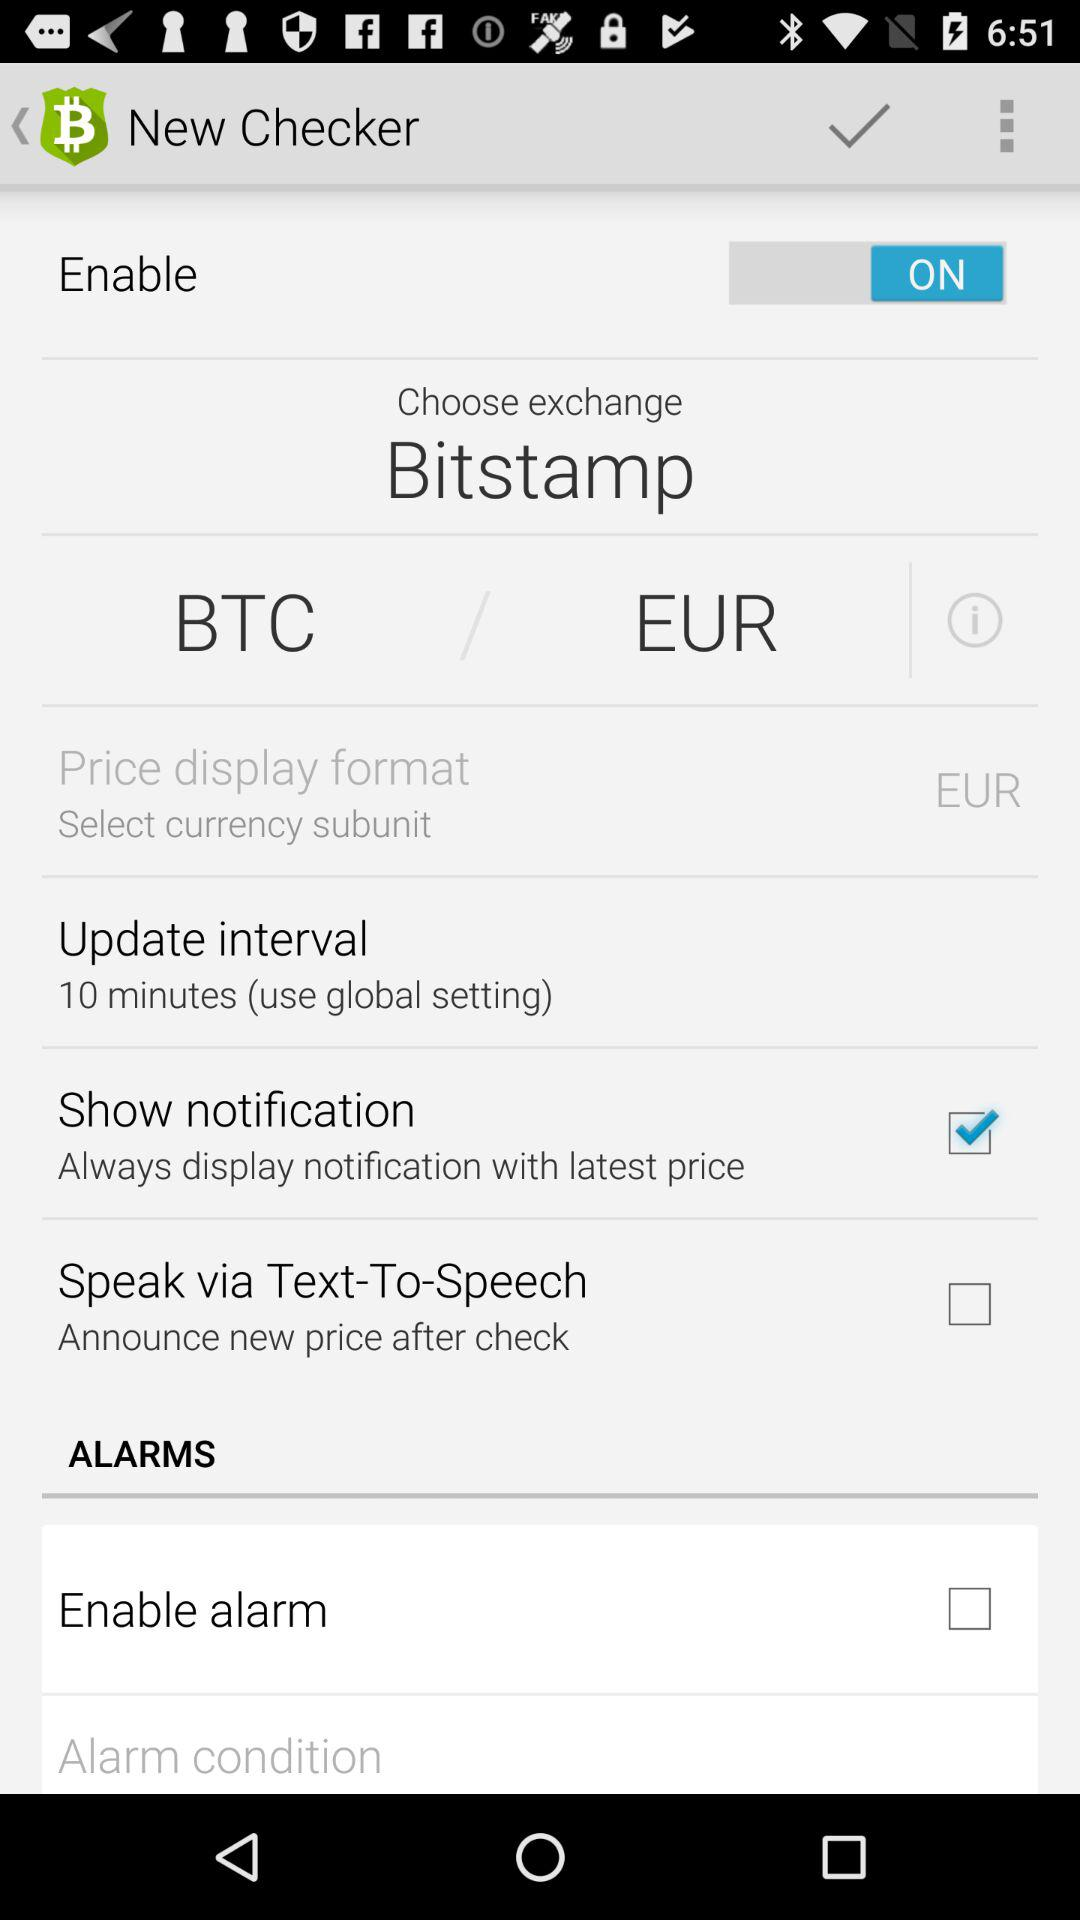What is the chosen crypto exchange? The chosen crypto exchange is "Bitstamp". 